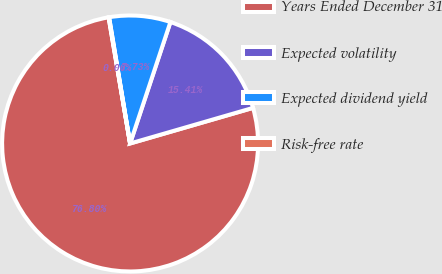Convert chart to OTSL. <chart><loc_0><loc_0><loc_500><loc_500><pie_chart><fcel>Years Ended December 31<fcel>Expected volatility<fcel>Expected dividend yield<fcel>Risk-free rate<nl><fcel>76.8%<fcel>15.41%<fcel>7.73%<fcel>0.06%<nl></chart> 